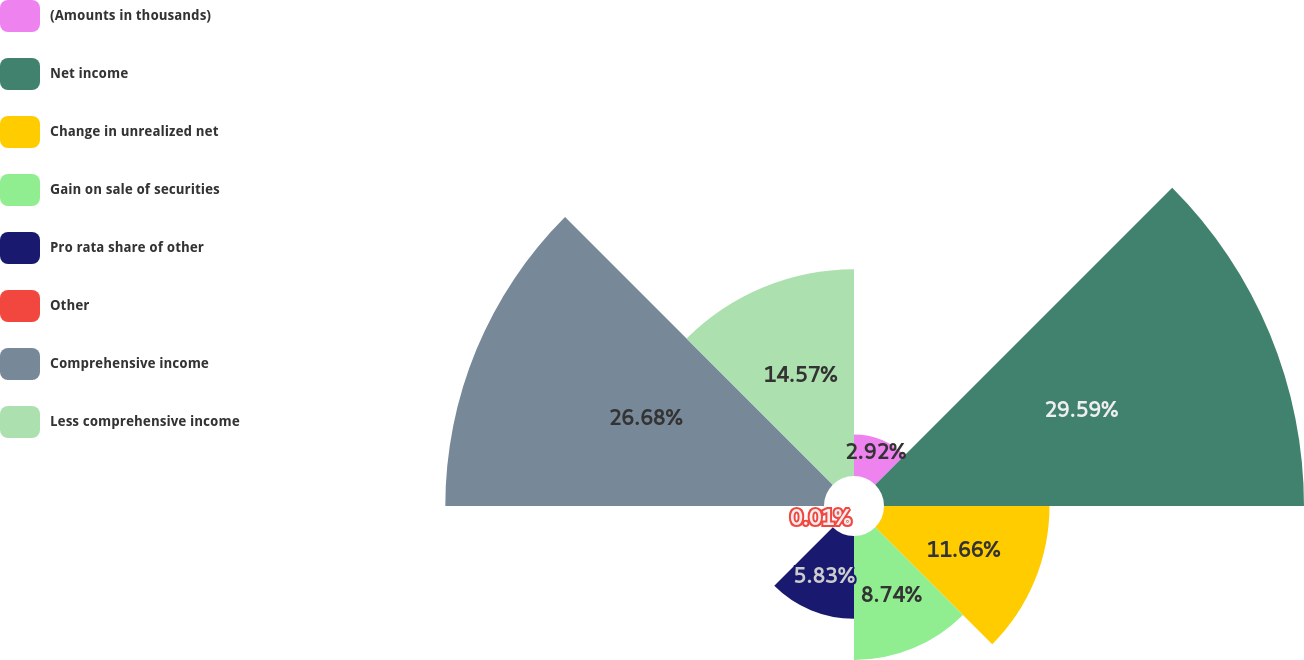<chart> <loc_0><loc_0><loc_500><loc_500><pie_chart><fcel>(Amounts in thousands)<fcel>Net income<fcel>Change in unrealized net<fcel>Gain on sale of securities<fcel>Pro rata share of other<fcel>Other<fcel>Comprehensive income<fcel>Less comprehensive income<nl><fcel>2.92%<fcel>29.59%<fcel>11.66%<fcel>8.74%<fcel>5.83%<fcel>0.01%<fcel>26.68%<fcel>14.57%<nl></chart> 